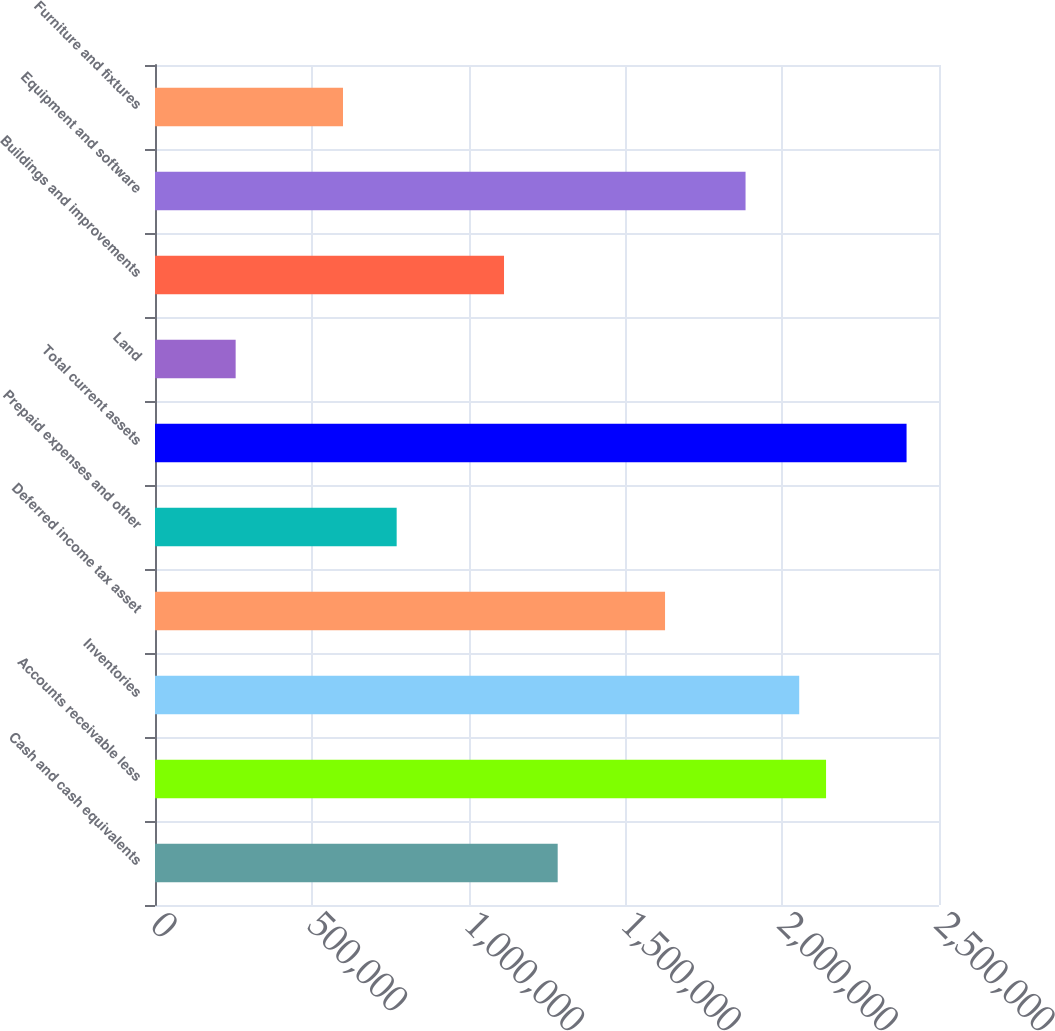Convert chart. <chart><loc_0><loc_0><loc_500><loc_500><bar_chart><fcel>Cash and cash equivalents<fcel>Accounts receivable less<fcel>Inventories<fcel>Deferred income tax asset<fcel>Prepaid expenses and other<fcel>Total current assets<fcel>Land<fcel>Buildings and improvements<fcel>Equipment and software<fcel>Furniture and fixtures<nl><fcel>1.28409e+06<fcel>2.13985e+06<fcel>2.05427e+06<fcel>1.62639e+06<fcel>770629<fcel>2.39658e+06<fcel>257171<fcel>1.11293e+06<fcel>1.88312e+06<fcel>599476<nl></chart> 